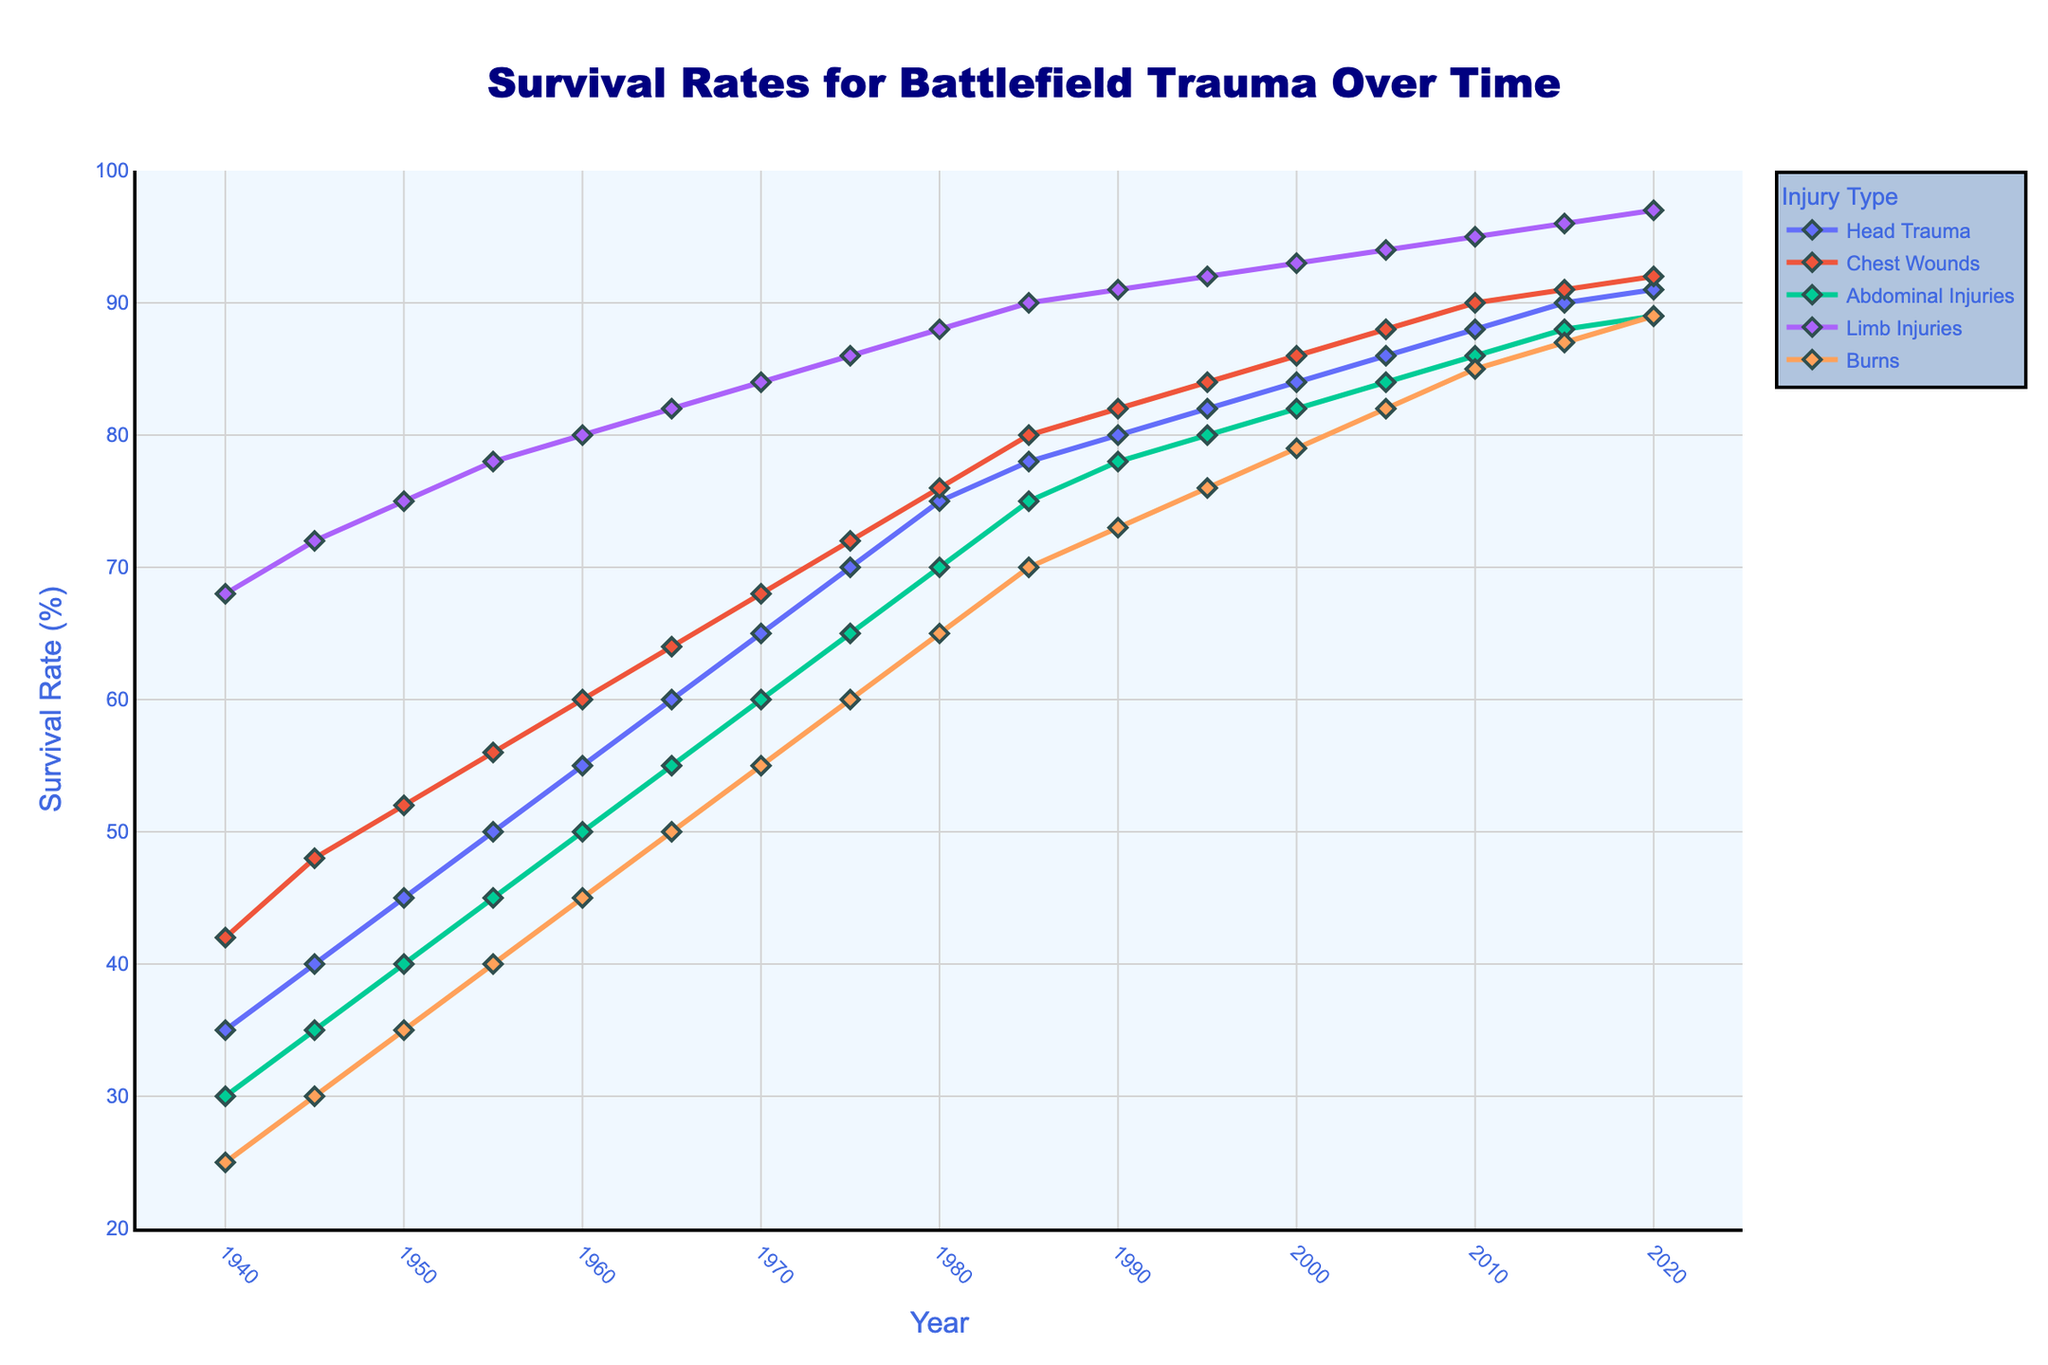How have the survival rates for head trauma changed from 1940 to 2020? To determine the change in survival rates for head trauma, find the rate in 1940 and 2020 in the line chart. In 1940, it was 35%, and in 2020, it was 91%. Calculate the difference: 91% - 35% = 56%.
Answer: 56% Which type of injury had the highest survival rate in 1980? Check the survival rates for all injury types in 1980. Head trauma was 75%, chest wounds were 76%, abdominal injuries were 70%, limb injuries were 88%, and burns were 65%. Limb injuries had the highest survival rate at 88%.
Answer: Limb injuries By how much did the survival rate for burns increase between 1940 and 2010? Identify the survival rates for burns in both years: 25% in 1940 and 85% in 2010. Calculate the increase: 85% - 25% = 60%.
Answer: 60% Which injury types had survival rates of at least 90% by 2020? Look at the survival rates of all injury types in 2020. Head trauma was 91%, chest wounds were 92%, abdominal injuries were 89%, limb injuries were 97%, and burns were 89%. Head trauma, chest wounds, and limb injuries all had survival rates of at least 90%.
Answer: Head trauma, Chest wounds, Limb injuries What is the average survival rate for chest wounds between 1940 and 2020? Sum the survival rates for chest wounds for each year between 1940 and 2020, then divide by the number of years. (42+48+52+56+60+64+68+72+76+80+82+84+86+88+90+91+92) / 17 = 73.3%.
Answer: 73.3% By how much did the survival rate for abdominal injuries increase between 1955 and 2005? Identify the survival rates for abdominal injuries in 1955 and 2005. In 1955, the rate was 45%, and in 2005, it was 84%. Calculate the increase: 84% - 45% = 39%.
Answer: 39% Which injury type showed the most consistent increase in survival rates over the years represented in the figure? Compare the lines representing survival rates for different injury types and determine which has the smoothest, most consistent upward trend. Upon visual inspection, all lines show a steady increase, but limb injuries have the most consistently smooth increase.
Answer: Limb injuries When did the survival rate for limb injuries first surpass 90%? Identify the point in time when the survival rate for limb injuries exceeded 90%. Based on the chart, this happened in 1985 when the survival rate reached 90%.
Answer: 1985 What was the survival rate for abdominal injuries in 1965 and how does it compare to the survival rate for burns in the same year? Find the survival rates for abdominal injuries and burns in 1965. Abdominal injuries had a survival rate of 55%, and burns had a survival rate of 50%. Compare them: 55% - 50% = 5%. Abdominal injuries had a 5% higher survival rate than burns.
Answer: 5% higher 